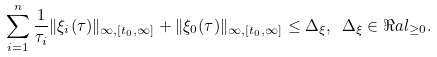Convert formula to latex. <formula><loc_0><loc_0><loc_500><loc_500>\sum _ { i = 1 } ^ { n } \frac { 1 } { \tau _ { i } } \| \xi _ { i } ( \tau ) \| _ { \infty , [ t _ { 0 } , \infty ] } + \| \xi _ { 0 } ( \tau ) \| _ { \infty , [ t _ { 0 } , \infty ] } \leq \Delta _ { \xi } , \ \Delta _ { \xi } \in \Re a l _ { \geq 0 } .</formula> 